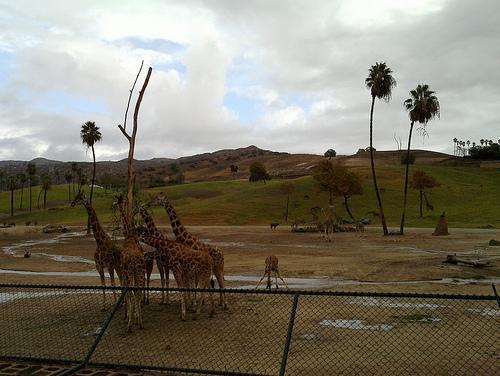How many giraffe are standing together?
Give a very brief answer. 4. 